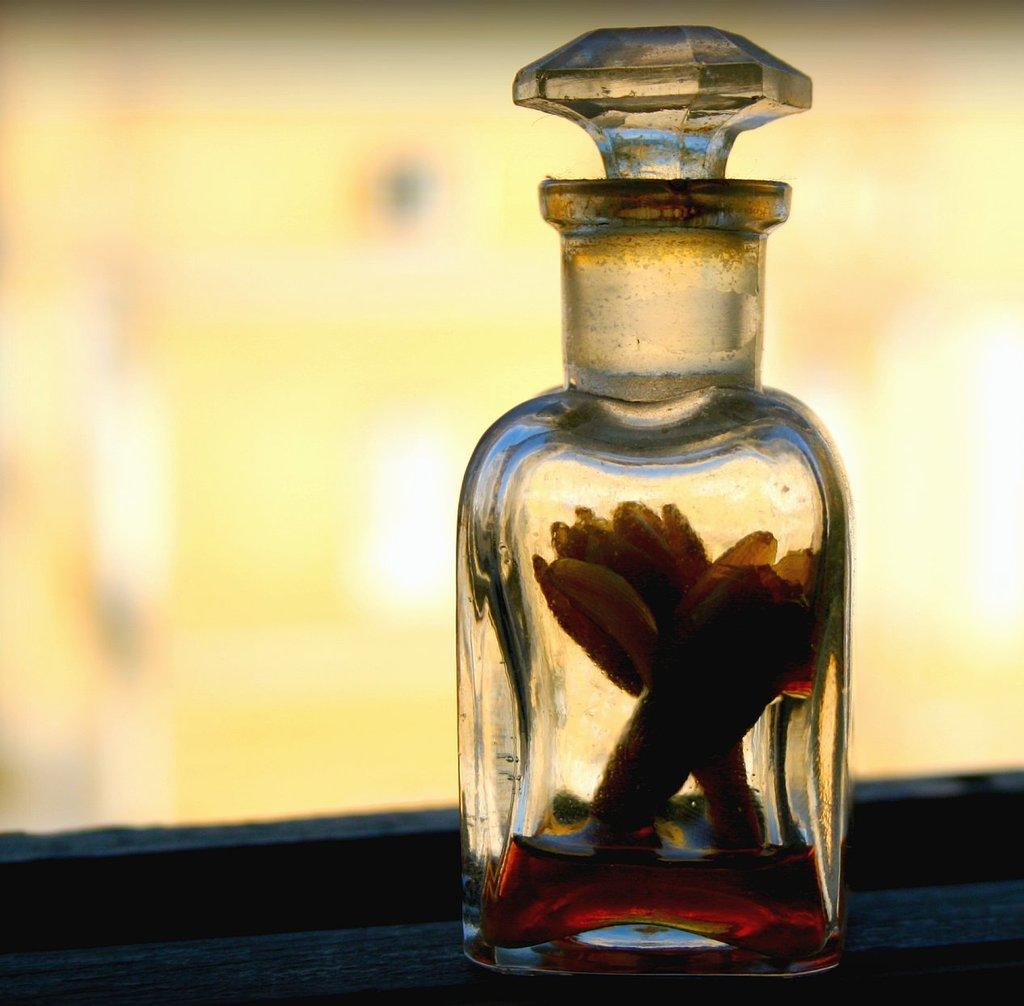What is the main object visible in the image? There is a glass bottle in the image. Is there anything inside the glass bottle? Yes, there is an object placed inside the glass bottle. What type of action is the glass bottle performing in the image? The glass bottle is not performing any action in the image; it is stationary. What type of fruit can be seen inside the glass bottle? There is no fruit visible inside the glass bottle; only an object is mentioned. 